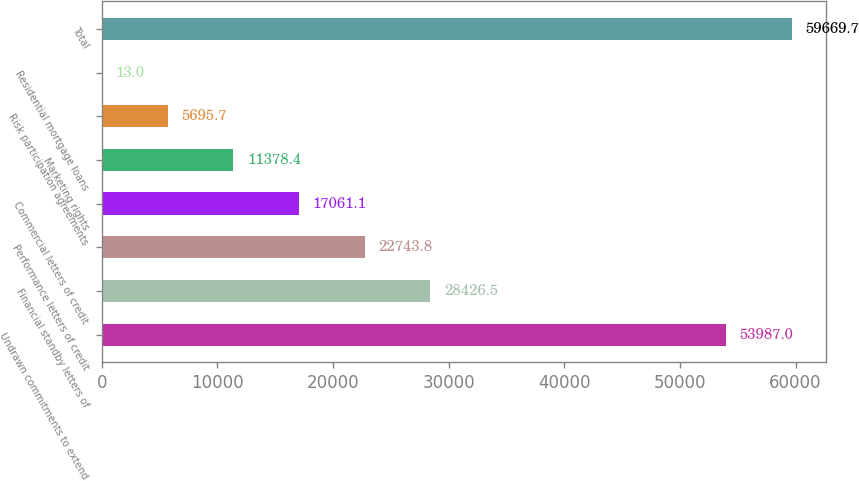Convert chart. <chart><loc_0><loc_0><loc_500><loc_500><bar_chart><fcel>Undrawn commitments to extend<fcel>Financial standby letters of<fcel>Performance letters of credit<fcel>Commercial letters of credit<fcel>Marketing rights<fcel>Risk participation agreements<fcel>Residential mortgage loans<fcel>Total<nl><fcel>53987<fcel>28426.5<fcel>22743.8<fcel>17061.1<fcel>11378.4<fcel>5695.7<fcel>13<fcel>59669.7<nl></chart> 